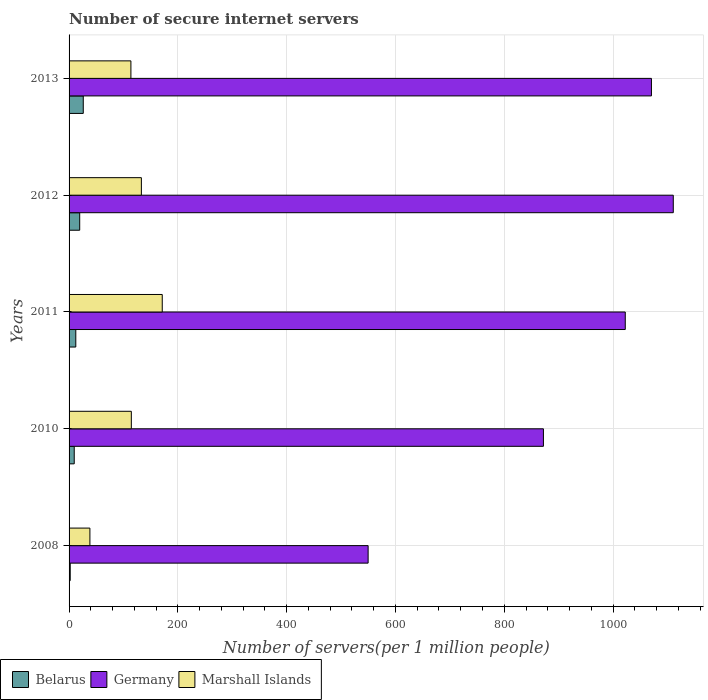Are the number of bars per tick equal to the number of legend labels?
Your response must be concise. Yes. How many bars are there on the 2nd tick from the bottom?
Offer a very short reply. 3. What is the label of the 2nd group of bars from the top?
Offer a very short reply. 2012. What is the number of secure internet servers in Germany in 2011?
Your answer should be compact. 1022.51. Across all years, what is the maximum number of secure internet servers in Marshall Islands?
Make the answer very short. 171.29. Across all years, what is the minimum number of secure internet servers in Germany?
Offer a terse response. 549.79. In which year was the number of secure internet servers in Belarus maximum?
Provide a short and direct response. 2013. In which year was the number of secure internet servers in Belarus minimum?
Your answer should be very brief. 2008. What is the total number of secure internet servers in Germany in the graph?
Provide a succinct answer. 4625.71. What is the difference between the number of secure internet servers in Marshall Islands in 2010 and that in 2013?
Give a very brief answer. 0.78. What is the difference between the number of secure internet servers in Germany in 2010 and the number of secure internet servers in Marshall Islands in 2012?
Your answer should be very brief. 739.11. What is the average number of secure internet servers in Germany per year?
Keep it short and to the point. 925.14. In the year 2011, what is the difference between the number of secure internet servers in Belarus and number of secure internet servers in Marshall Islands?
Your answer should be very brief. -158.94. What is the ratio of the number of secure internet servers in Germany in 2008 to that in 2011?
Keep it short and to the point. 0.54. Is the number of secure internet servers in Marshall Islands in 2008 less than that in 2012?
Provide a short and direct response. Yes. What is the difference between the highest and the second highest number of secure internet servers in Germany?
Your response must be concise. 40.16. What is the difference between the highest and the lowest number of secure internet servers in Belarus?
Provide a short and direct response. 23.99. Is the sum of the number of secure internet servers in Belarus in 2008 and 2012 greater than the maximum number of secure internet servers in Marshall Islands across all years?
Provide a short and direct response. No. What does the 2nd bar from the bottom in 2010 represents?
Offer a very short reply. Germany. Is it the case that in every year, the sum of the number of secure internet servers in Belarus and number of secure internet servers in Germany is greater than the number of secure internet servers in Marshall Islands?
Provide a succinct answer. Yes. Are all the bars in the graph horizontal?
Provide a short and direct response. Yes. What is the difference between two consecutive major ticks on the X-axis?
Provide a short and direct response. 200. Are the values on the major ticks of X-axis written in scientific E-notation?
Offer a very short reply. No. Does the graph contain any zero values?
Make the answer very short. No. Where does the legend appear in the graph?
Provide a short and direct response. Bottom left. How many legend labels are there?
Make the answer very short. 3. What is the title of the graph?
Provide a short and direct response. Number of secure internet servers. Does "Comoros" appear as one of the legend labels in the graph?
Ensure brevity in your answer.  No. What is the label or title of the X-axis?
Make the answer very short. Number of servers(per 1 million people). What is the Number of servers(per 1 million people) in Belarus in 2008?
Your answer should be compact. 2.1. What is the Number of servers(per 1 million people) in Germany in 2008?
Give a very brief answer. 549.79. What is the Number of servers(per 1 million people) of Marshall Islands in 2008?
Your response must be concise. 38.3. What is the Number of servers(per 1 million people) of Belarus in 2010?
Give a very brief answer. 9.48. What is the Number of servers(per 1 million people) of Germany in 2010?
Provide a succinct answer. 872.03. What is the Number of servers(per 1 million people) in Marshall Islands in 2010?
Your answer should be very brief. 114.44. What is the Number of servers(per 1 million people) of Belarus in 2011?
Offer a terse response. 12.35. What is the Number of servers(per 1 million people) of Germany in 2011?
Offer a very short reply. 1022.51. What is the Number of servers(per 1 million people) of Marshall Islands in 2011?
Provide a succinct answer. 171.29. What is the Number of servers(per 1 million people) in Belarus in 2012?
Your answer should be very brief. 19.55. What is the Number of servers(per 1 million people) of Germany in 2012?
Your response must be concise. 1110.78. What is the Number of servers(per 1 million people) of Marshall Islands in 2012?
Provide a short and direct response. 132.92. What is the Number of servers(per 1 million people) in Belarus in 2013?
Provide a succinct answer. 26.09. What is the Number of servers(per 1 million people) of Germany in 2013?
Ensure brevity in your answer.  1070.61. What is the Number of servers(per 1 million people) in Marshall Islands in 2013?
Make the answer very short. 113.67. Across all years, what is the maximum Number of servers(per 1 million people) of Belarus?
Offer a terse response. 26.09. Across all years, what is the maximum Number of servers(per 1 million people) of Germany?
Provide a succinct answer. 1110.78. Across all years, what is the maximum Number of servers(per 1 million people) in Marshall Islands?
Offer a terse response. 171.29. Across all years, what is the minimum Number of servers(per 1 million people) of Belarus?
Make the answer very short. 2.1. Across all years, what is the minimum Number of servers(per 1 million people) of Germany?
Make the answer very short. 549.79. Across all years, what is the minimum Number of servers(per 1 million people) in Marshall Islands?
Ensure brevity in your answer.  38.3. What is the total Number of servers(per 1 million people) in Belarus in the graph?
Offer a terse response. 69.57. What is the total Number of servers(per 1 million people) in Germany in the graph?
Ensure brevity in your answer.  4625.71. What is the total Number of servers(per 1 million people) in Marshall Islands in the graph?
Your answer should be compact. 570.62. What is the difference between the Number of servers(per 1 million people) of Belarus in 2008 and that in 2010?
Offer a very short reply. -7.38. What is the difference between the Number of servers(per 1 million people) in Germany in 2008 and that in 2010?
Your response must be concise. -322.24. What is the difference between the Number of servers(per 1 million people) in Marshall Islands in 2008 and that in 2010?
Provide a succinct answer. -76.14. What is the difference between the Number of servers(per 1 million people) of Belarus in 2008 and that in 2011?
Give a very brief answer. -10.25. What is the difference between the Number of servers(per 1 million people) in Germany in 2008 and that in 2011?
Provide a succinct answer. -472.72. What is the difference between the Number of servers(per 1 million people) of Marshall Islands in 2008 and that in 2011?
Keep it short and to the point. -133. What is the difference between the Number of servers(per 1 million people) in Belarus in 2008 and that in 2012?
Provide a short and direct response. -17.45. What is the difference between the Number of servers(per 1 million people) in Germany in 2008 and that in 2012?
Keep it short and to the point. -560.99. What is the difference between the Number of servers(per 1 million people) of Marshall Islands in 2008 and that in 2012?
Give a very brief answer. -94.62. What is the difference between the Number of servers(per 1 million people) of Belarus in 2008 and that in 2013?
Keep it short and to the point. -23.99. What is the difference between the Number of servers(per 1 million people) of Germany in 2008 and that in 2013?
Offer a terse response. -520.82. What is the difference between the Number of servers(per 1 million people) of Marshall Islands in 2008 and that in 2013?
Ensure brevity in your answer.  -75.37. What is the difference between the Number of servers(per 1 million people) of Belarus in 2010 and that in 2011?
Your answer should be very brief. -2.87. What is the difference between the Number of servers(per 1 million people) in Germany in 2010 and that in 2011?
Offer a terse response. -150.48. What is the difference between the Number of servers(per 1 million people) of Marshall Islands in 2010 and that in 2011?
Offer a terse response. -56.85. What is the difference between the Number of servers(per 1 million people) in Belarus in 2010 and that in 2012?
Give a very brief answer. -10.06. What is the difference between the Number of servers(per 1 million people) in Germany in 2010 and that in 2012?
Give a very brief answer. -238.74. What is the difference between the Number of servers(per 1 million people) of Marshall Islands in 2010 and that in 2012?
Your answer should be very brief. -18.48. What is the difference between the Number of servers(per 1 million people) of Belarus in 2010 and that in 2013?
Keep it short and to the point. -16.61. What is the difference between the Number of servers(per 1 million people) of Germany in 2010 and that in 2013?
Keep it short and to the point. -198.58. What is the difference between the Number of servers(per 1 million people) in Marshall Islands in 2010 and that in 2013?
Offer a very short reply. 0.78. What is the difference between the Number of servers(per 1 million people) of Belarus in 2011 and that in 2012?
Ensure brevity in your answer.  -7.2. What is the difference between the Number of servers(per 1 million people) in Germany in 2011 and that in 2012?
Your answer should be compact. -88.26. What is the difference between the Number of servers(per 1 million people) in Marshall Islands in 2011 and that in 2012?
Your response must be concise. 38.37. What is the difference between the Number of servers(per 1 million people) of Belarus in 2011 and that in 2013?
Ensure brevity in your answer.  -13.74. What is the difference between the Number of servers(per 1 million people) of Germany in 2011 and that in 2013?
Provide a succinct answer. -48.1. What is the difference between the Number of servers(per 1 million people) of Marshall Islands in 2011 and that in 2013?
Keep it short and to the point. 57.63. What is the difference between the Number of servers(per 1 million people) of Belarus in 2012 and that in 2013?
Provide a succinct answer. -6.55. What is the difference between the Number of servers(per 1 million people) in Germany in 2012 and that in 2013?
Keep it short and to the point. 40.16. What is the difference between the Number of servers(per 1 million people) in Marshall Islands in 2012 and that in 2013?
Provide a short and direct response. 19.25. What is the difference between the Number of servers(per 1 million people) in Belarus in 2008 and the Number of servers(per 1 million people) in Germany in 2010?
Ensure brevity in your answer.  -869.93. What is the difference between the Number of servers(per 1 million people) in Belarus in 2008 and the Number of servers(per 1 million people) in Marshall Islands in 2010?
Your answer should be compact. -112.34. What is the difference between the Number of servers(per 1 million people) in Germany in 2008 and the Number of servers(per 1 million people) in Marshall Islands in 2010?
Give a very brief answer. 435.34. What is the difference between the Number of servers(per 1 million people) in Belarus in 2008 and the Number of servers(per 1 million people) in Germany in 2011?
Give a very brief answer. -1020.41. What is the difference between the Number of servers(per 1 million people) of Belarus in 2008 and the Number of servers(per 1 million people) of Marshall Islands in 2011?
Your answer should be compact. -169.2. What is the difference between the Number of servers(per 1 million people) in Germany in 2008 and the Number of servers(per 1 million people) in Marshall Islands in 2011?
Provide a succinct answer. 378.49. What is the difference between the Number of servers(per 1 million people) in Belarus in 2008 and the Number of servers(per 1 million people) in Germany in 2012?
Your response must be concise. -1108.68. What is the difference between the Number of servers(per 1 million people) of Belarus in 2008 and the Number of servers(per 1 million people) of Marshall Islands in 2012?
Give a very brief answer. -130.82. What is the difference between the Number of servers(per 1 million people) in Germany in 2008 and the Number of servers(per 1 million people) in Marshall Islands in 2012?
Make the answer very short. 416.87. What is the difference between the Number of servers(per 1 million people) in Belarus in 2008 and the Number of servers(per 1 million people) in Germany in 2013?
Your answer should be compact. -1068.51. What is the difference between the Number of servers(per 1 million people) of Belarus in 2008 and the Number of servers(per 1 million people) of Marshall Islands in 2013?
Make the answer very short. -111.57. What is the difference between the Number of servers(per 1 million people) in Germany in 2008 and the Number of servers(per 1 million people) in Marshall Islands in 2013?
Give a very brief answer. 436.12. What is the difference between the Number of servers(per 1 million people) in Belarus in 2010 and the Number of servers(per 1 million people) in Germany in 2011?
Keep it short and to the point. -1013.03. What is the difference between the Number of servers(per 1 million people) in Belarus in 2010 and the Number of servers(per 1 million people) in Marshall Islands in 2011?
Offer a terse response. -161.81. What is the difference between the Number of servers(per 1 million people) in Germany in 2010 and the Number of servers(per 1 million people) in Marshall Islands in 2011?
Keep it short and to the point. 700.74. What is the difference between the Number of servers(per 1 million people) in Belarus in 2010 and the Number of servers(per 1 million people) in Germany in 2012?
Your answer should be very brief. -1101.29. What is the difference between the Number of servers(per 1 million people) of Belarus in 2010 and the Number of servers(per 1 million people) of Marshall Islands in 2012?
Your answer should be very brief. -123.44. What is the difference between the Number of servers(per 1 million people) in Germany in 2010 and the Number of servers(per 1 million people) in Marshall Islands in 2012?
Make the answer very short. 739.11. What is the difference between the Number of servers(per 1 million people) of Belarus in 2010 and the Number of servers(per 1 million people) of Germany in 2013?
Your answer should be compact. -1061.13. What is the difference between the Number of servers(per 1 million people) in Belarus in 2010 and the Number of servers(per 1 million people) in Marshall Islands in 2013?
Your answer should be compact. -104.18. What is the difference between the Number of servers(per 1 million people) in Germany in 2010 and the Number of servers(per 1 million people) in Marshall Islands in 2013?
Your answer should be compact. 758.36. What is the difference between the Number of servers(per 1 million people) in Belarus in 2011 and the Number of servers(per 1 million people) in Germany in 2012?
Keep it short and to the point. -1098.42. What is the difference between the Number of servers(per 1 million people) of Belarus in 2011 and the Number of servers(per 1 million people) of Marshall Islands in 2012?
Your response must be concise. -120.57. What is the difference between the Number of servers(per 1 million people) in Germany in 2011 and the Number of servers(per 1 million people) in Marshall Islands in 2012?
Offer a very short reply. 889.59. What is the difference between the Number of servers(per 1 million people) of Belarus in 2011 and the Number of servers(per 1 million people) of Germany in 2013?
Offer a terse response. -1058.26. What is the difference between the Number of servers(per 1 million people) in Belarus in 2011 and the Number of servers(per 1 million people) in Marshall Islands in 2013?
Offer a very short reply. -101.32. What is the difference between the Number of servers(per 1 million people) in Germany in 2011 and the Number of servers(per 1 million people) in Marshall Islands in 2013?
Provide a short and direct response. 908.84. What is the difference between the Number of servers(per 1 million people) in Belarus in 2012 and the Number of servers(per 1 million people) in Germany in 2013?
Ensure brevity in your answer.  -1051.06. What is the difference between the Number of servers(per 1 million people) of Belarus in 2012 and the Number of servers(per 1 million people) of Marshall Islands in 2013?
Keep it short and to the point. -94.12. What is the difference between the Number of servers(per 1 million people) in Germany in 2012 and the Number of servers(per 1 million people) in Marshall Islands in 2013?
Offer a terse response. 997.11. What is the average Number of servers(per 1 million people) of Belarus per year?
Make the answer very short. 13.91. What is the average Number of servers(per 1 million people) of Germany per year?
Your answer should be compact. 925.14. What is the average Number of servers(per 1 million people) of Marshall Islands per year?
Your response must be concise. 114.12. In the year 2008, what is the difference between the Number of servers(per 1 million people) in Belarus and Number of servers(per 1 million people) in Germany?
Ensure brevity in your answer.  -547.69. In the year 2008, what is the difference between the Number of servers(per 1 million people) of Belarus and Number of servers(per 1 million people) of Marshall Islands?
Your response must be concise. -36.2. In the year 2008, what is the difference between the Number of servers(per 1 million people) of Germany and Number of servers(per 1 million people) of Marshall Islands?
Provide a succinct answer. 511.49. In the year 2010, what is the difference between the Number of servers(per 1 million people) of Belarus and Number of servers(per 1 million people) of Germany?
Provide a succinct answer. -862.55. In the year 2010, what is the difference between the Number of servers(per 1 million people) of Belarus and Number of servers(per 1 million people) of Marshall Islands?
Your answer should be very brief. -104.96. In the year 2010, what is the difference between the Number of servers(per 1 million people) in Germany and Number of servers(per 1 million people) in Marshall Islands?
Provide a succinct answer. 757.59. In the year 2011, what is the difference between the Number of servers(per 1 million people) of Belarus and Number of servers(per 1 million people) of Germany?
Your response must be concise. -1010.16. In the year 2011, what is the difference between the Number of servers(per 1 million people) in Belarus and Number of servers(per 1 million people) in Marshall Islands?
Make the answer very short. -158.94. In the year 2011, what is the difference between the Number of servers(per 1 million people) of Germany and Number of servers(per 1 million people) of Marshall Islands?
Provide a succinct answer. 851.22. In the year 2012, what is the difference between the Number of servers(per 1 million people) of Belarus and Number of servers(per 1 million people) of Germany?
Ensure brevity in your answer.  -1091.23. In the year 2012, what is the difference between the Number of servers(per 1 million people) in Belarus and Number of servers(per 1 million people) in Marshall Islands?
Offer a terse response. -113.37. In the year 2012, what is the difference between the Number of servers(per 1 million people) of Germany and Number of servers(per 1 million people) of Marshall Islands?
Keep it short and to the point. 977.85. In the year 2013, what is the difference between the Number of servers(per 1 million people) in Belarus and Number of servers(per 1 million people) in Germany?
Make the answer very short. -1044.52. In the year 2013, what is the difference between the Number of servers(per 1 million people) of Belarus and Number of servers(per 1 million people) of Marshall Islands?
Your response must be concise. -87.57. In the year 2013, what is the difference between the Number of servers(per 1 million people) of Germany and Number of servers(per 1 million people) of Marshall Islands?
Your response must be concise. 956.94. What is the ratio of the Number of servers(per 1 million people) in Belarus in 2008 to that in 2010?
Keep it short and to the point. 0.22. What is the ratio of the Number of servers(per 1 million people) of Germany in 2008 to that in 2010?
Your answer should be very brief. 0.63. What is the ratio of the Number of servers(per 1 million people) in Marshall Islands in 2008 to that in 2010?
Provide a short and direct response. 0.33. What is the ratio of the Number of servers(per 1 million people) in Belarus in 2008 to that in 2011?
Provide a short and direct response. 0.17. What is the ratio of the Number of servers(per 1 million people) of Germany in 2008 to that in 2011?
Provide a short and direct response. 0.54. What is the ratio of the Number of servers(per 1 million people) in Marshall Islands in 2008 to that in 2011?
Make the answer very short. 0.22. What is the ratio of the Number of servers(per 1 million people) of Belarus in 2008 to that in 2012?
Your answer should be very brief. 0.11. What is the ratio of the Number of servers(per 1 million people) in Germany in 2008 to that in 2012?
Offer a very short reply. 0.49. What is the ratio of the Number of servers(per 1 million people) in Marshall Islands in 2008 to that in 2012?
Your answer should be very brief. 0.29. What is the ratio of the Number of servers(per 1 million people) of Belarus in 2008 to that in 2013?
Keep it short and to the point. 0.08. What is the ratio of the Number of servers(per 1 million people) in Germany in 2008 to that in 2013?
Ensure brevity in your answer.  0.51. What is the ratio of the Number of servers(per 1 million people) of Marshall Islands in 2008 to that in 2013?
Your response must be concise. 0.34. What is the ratio of the Number of servers(per 1 million people) of Belarus in 2010 to that in 2011?
Make the answer very short. 0.77. What is the ratio of the Number of servers(per 1 million people) of Germany in 2010 to that in 2011?
Make the answer very short. 0.85. What is the ratio of the Number of servers(per 1 million people) in Marshall Islands in 2010 to that in 2011?
Give a very brief answer. 0.67. What is the ratio of the Number of servers(per 1 million people) of Belarus in 2010 to that in 2012?
Ensure brevity in your answer.  0.49. What is the ratio of the Number of servers(per 1 million people) of Germany in 2010 to that in 2012?
Your answer should be compact. 0.79. What is the ratio of the Number of servers(per 1 million people) of Marshall Islands in 2010 to that in 2012?
Offer a terse response. 0.86. What is the ratio of the Number of servers(per 1 million people) in Belarus in 2010 to that in 2013?
Provide a succinct answer. 0.36. What is the ratio of the Number of servers(per 1 million people) in Germany in 2010 to that in 2013?
Offer a terse response. 0.81. What is the ratio of the Number of servers(per 1 million people) of Marshall Islands in 2010 to that in 2013?
Your answer should be compact. 1.01. What is the ratio of the Number of servers(per 1 million people) in Belarus in 2011 to that in 2012?
Your answer should be compact. 0.63. What is the ratio of the Number of servers(per 1 million people) of Germany in 2011 to that in 2012?
Give a very brief answer. 0.92. What is the ratio of the Number of servers(per 1 million people) of Marshall Islands in 2011 to that in 2012?
Your response must be concise. 1.29. What is the ratio of the Number of servers(per 1 million people) of Belarus in 2011 to that in 2013?
Ensure brevity in your answer.  0.47. What is the ratio of the Number of servers(per 1 million people) of Germany in 2011 to that in 2013?
Ensure brevity in your answer.  0.96. What is the ratio of the Number of servers(per 1 million people) in Marshall Islands in 2011 to that in 2013?
Keep it short and to the point. 1.51. What is the ratio of the Number of servers(per 1 million people) of Belarus in 2012 to that in 2013?
Your response must be concise. 0.75. What is the ratio of the Number of servers(per 1 million people) of Germany in 2012 to that in 2013?
Your answer should be compact. 1.04. What is the ratio of the Number of servers(per 1 million people) in Marshall Islands in 2012 to that in 2013?
Offer a very short reply. 1.17. What is the difference between the highest and the second highest Number of servers(per 1 million people) of Belarus?
Your answer should be very brief. 6.55. What is the difference between the highest and the second highest Number of servers(per 1 million people) in Germany?
Your answer should be compact. 40.16. What is the difference between the highest and the second highest Number of servers(per 1 million people) of Marshall Islands?
Keep it short and to the point. 38.37. What is the difference between the highest and the lowest Number of servers(per 1 million people) of Belarus?
Offer a terse response. 23.99. What is the difference between the highest and the lowest Number of servers(per 1 million people) in Germany?
Offer a terse response. 560.99. What is the difference between the highest and the lowest Number of servers(per 1 million people) in Marshall Islands?
Ensure brevity in your answer.  133. 